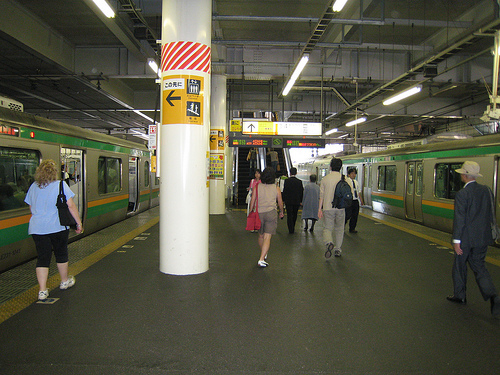<image>
Is the pillar to the left of the women? Yes. From this viewpoint, the pillar is positioned to the left side relative to the women. 